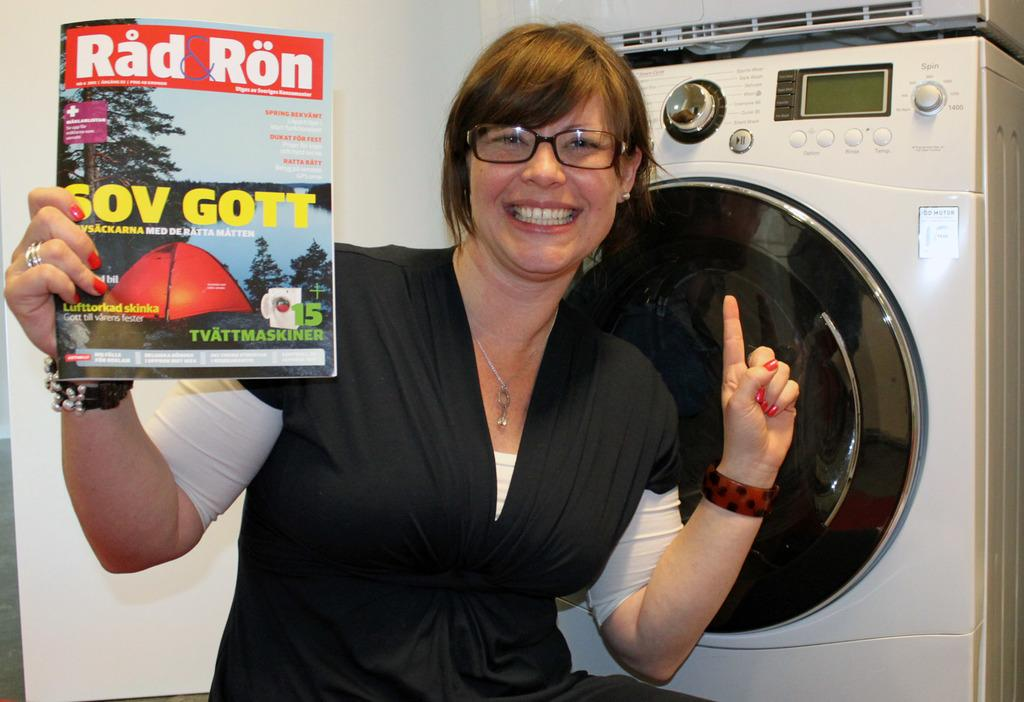<image>
Present a compact description of the photo's key features. a lady with glasses and a Red Ron magazine 